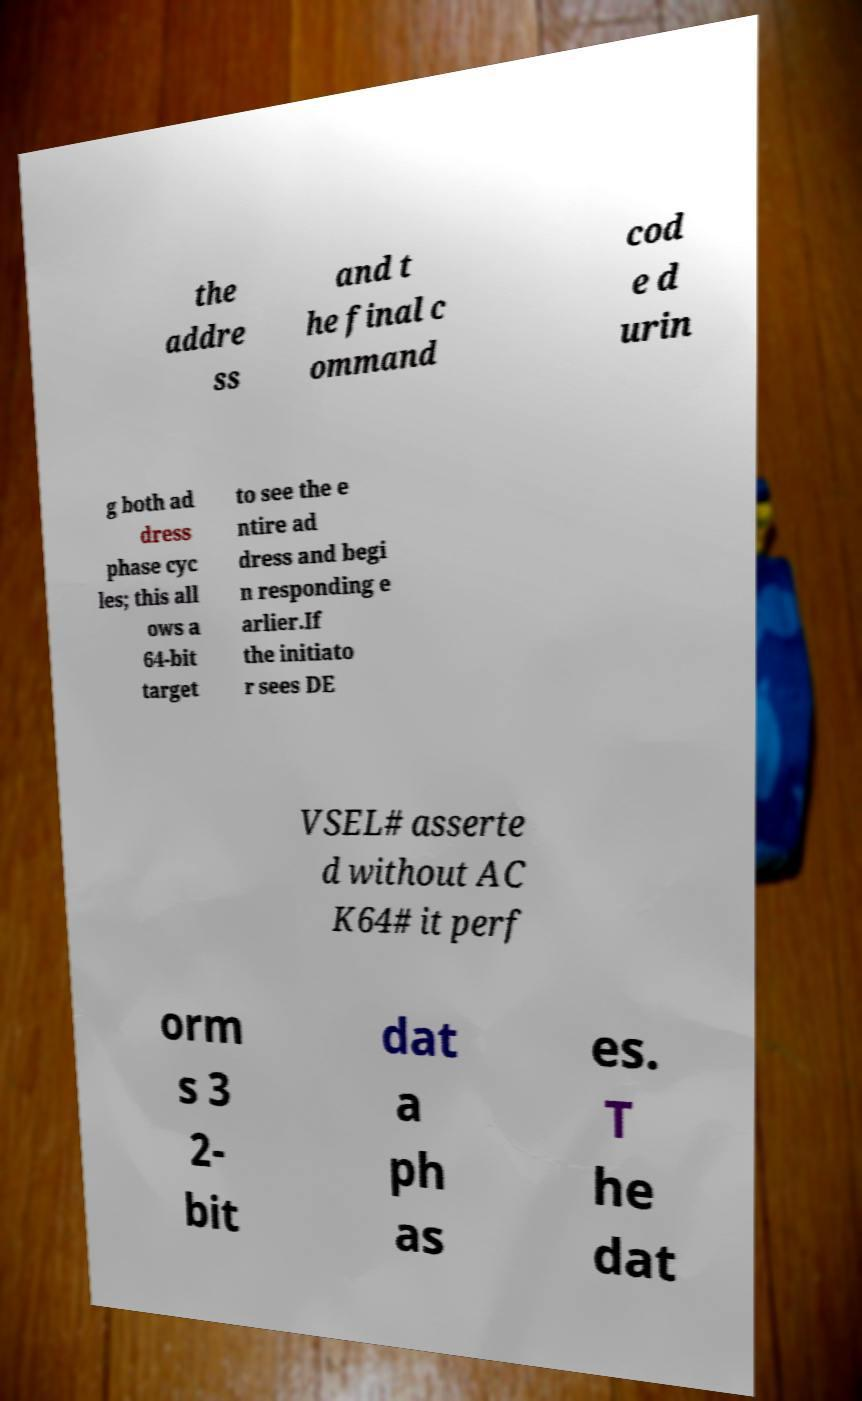Please read and relay the text visible in this image. What does it say? the addre ss and t he final c ommand cod e d urin g both ad dress phase cyc les; this all ows a 64-bit target to see the e ntire ad dress and begi n responding e arlier.If the initiato r sees DE VSEL# asserte d without AC K64# it perf orm s 3 2- bit dat a ph as es. T he dat 